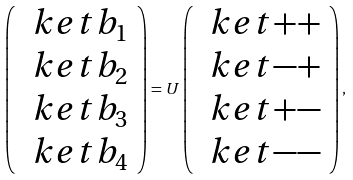Convert formula to latex. <formula><loc_0><loc_0><loc_500><loc_500>\left ( \begin{array} { c } \ k e t { b _ { 1 } } \\ \ k e t { b _ { 2 } } \\ \ k e t { b _ { 3 } } \\ \ k e t { b _ { 4 } } \end{array} \right ) = U \left ( \begin{array} { c } \ k e t { + + } \\ \ k e t { - + } \\ \ k e t { + - } \\ \ k e t { - - } \end{array} \right ) ,</formula> 